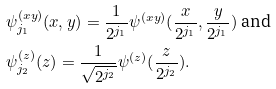Convert formula to latex. <formula><loc_0><loc_0><loc_500><loc_500>& \psi _ { j _ { 1 } } ^ { ( x y ) } ( x , y ) = \frac { 1 } { 2 ^ { j _ { 1 } } } \psi ^ { ( x y ) } ( \frac { x } { 2 ^ { j _ { 1 } } } , \frac { y } { 2 ^ { j _ { 1 } } } ) \text { and } \\ & \psi _ { j _ { 2 } } ^ { ( z ) } ( z ) = \frac { 1 } { \sqrt { 2 ^ { j _ { 2 } } } } \psi ^ { ( z ) } ( \frac { z } { 2 ^ { j _ { 2 } } } ) .</formula> 